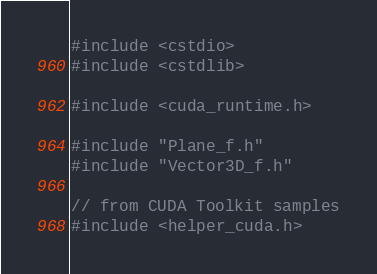Convert code to text. <code><loc_0><loc_0><loc_500><loc_500><_Cuda_>#include <cstdio>
#include <cstdlib>

#include <cuda_runtime.h>

#include "Plane_f.h"
#include "Vector3D_f.h"

// from CUDA Toolkit samples
#include <helper_cuda.h>
</code> 